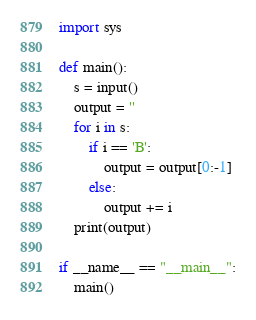<code> <loc_0><loc_0><loc_500><loc_500><_Python_>import sys

def main():
    s = input()
    output = ''
    for i in s:
        if i == 'B':
            output = output[0:-1]
        else:
            output += i
    print(output)

if __name__ == "__main__":
    main()</code> 